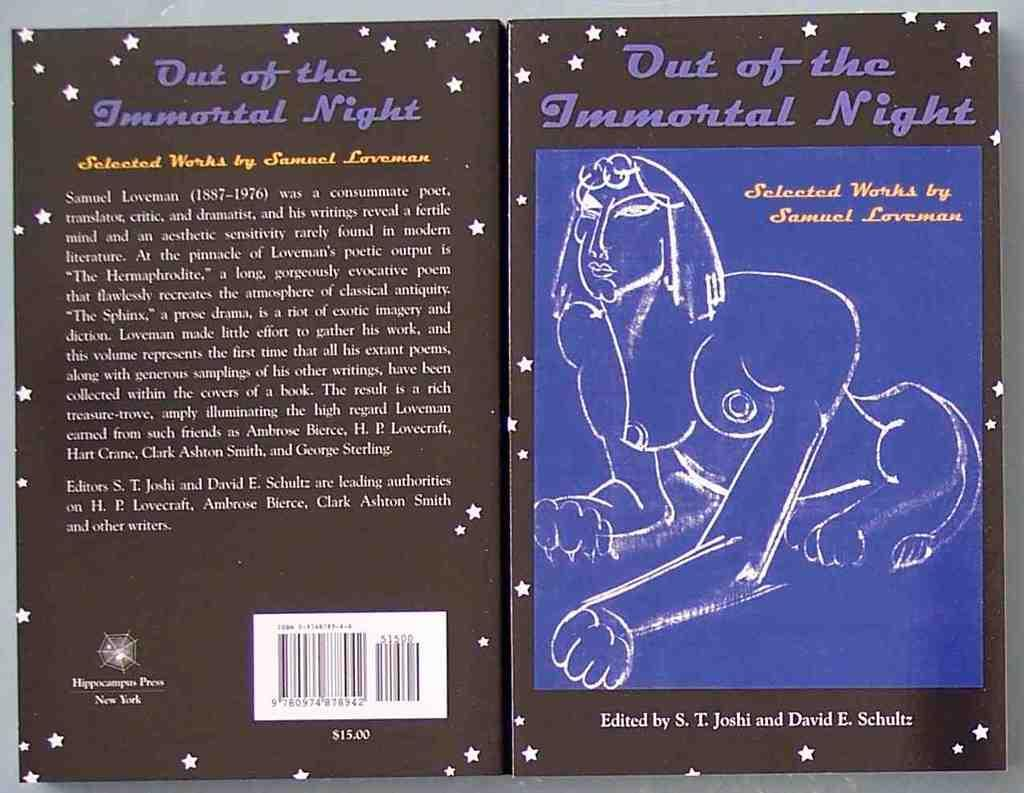Provide a one-sentence caption for the provided image. The front and back covers of Out of the Immortal night by Samuel Loveman is shown. 